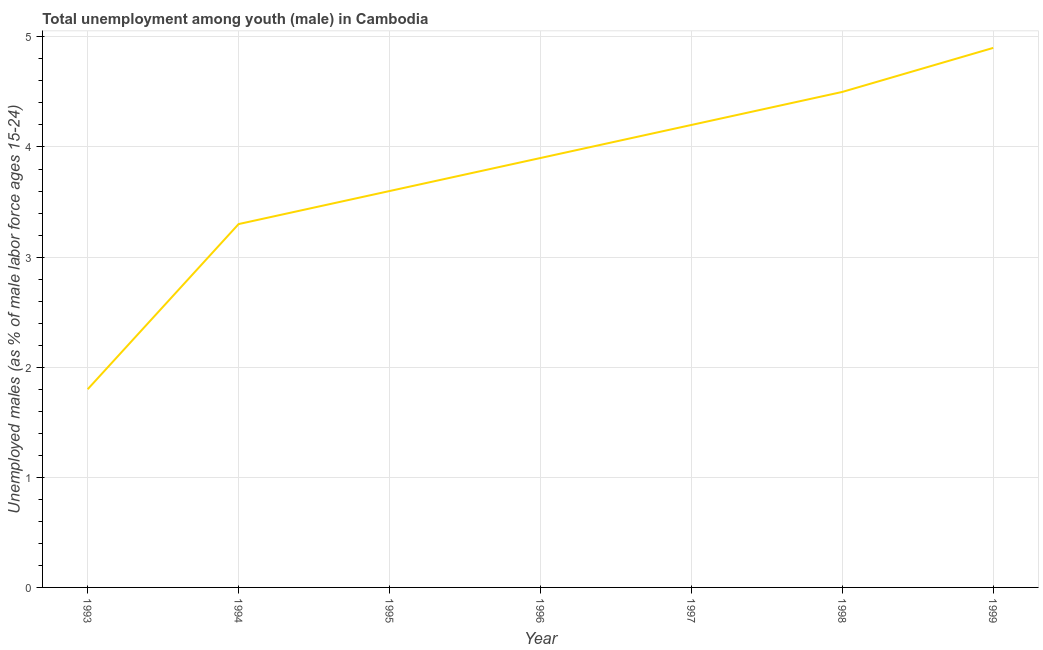Across all years, what is the maximum unemployed male youth population?
Offer a terse response. 4.9. Across all years, what is the minimum unemployed male youth population?
Offer a very short reply. 1.8. In which year was the unemployed male youth population minimum?
Keep it short and to the point. 1993. What is the sum of the unemployed male youth population?
Your answer should be very brief. 26.2. What is the difference between the unemployed male youth population in 1995 and 1998?
Ensure brevity in your answer.  -0.9. What is the average unemployed male youth population per year?
Keep it short and to the point. 3.74. What is the median unemployed male youth population?
Keep it short and to the point. 3.9. What is the ratio of the unemployed male youth population in 1996 to that in 1997?
Your answer should be very brief. 0.93. Is the unemployed male youth population in 1995 less than that in 1998?
Provide a short and direct response. Yes. What is the difference between the highest and the second highest unemployed male youth population?
Ensure brevity in your answer.  0.4. What is the difference between the highest and the lowest unemployed male youth population?
Your answer should be very brief. 3.1. In how many years, is the unemployed male youth population greater than the average unemployed male youth population taken over all years?
Ensure brevity in your answer.  4. How many lines are there?
Offer a very short reply. 1. How many years are there in the graph?
Give a very brief answer. 7. What is the title of the graph?
Give a very brief answer. Total unemployment among youth (male) in Cambodia. What is the label or title of the Y-axis?
Offer a very short reply. Unemployed males (as % of male labor force ages 15-24). What is the Unemployed males (as % of male labor force ages 15-24) in 1993?
Your answer should be very brief. 1.8. What is the Unemployed males (as % of male labor force ages 15-24) of 1994?
Offer a very short reply. 3.3. What is the Unemployed males (as % of male labor force ages 15-24) of 1995?
Ensure brevity in your answer.  3.6. What is the Unemployed males (as % of male labor force ages 15-24) in 1996?
Provide a succinct answer. 3.9. What is the Unemployed males (as % of male labor force ages 15-24) in 1997?
Give a very brief answer. 4.2. What is the Unemployed males (as % of male labor force ages 15-24) in 1999?
Make the answer very short. 4.9. What is the difference between the Unemployed males (as % of male labor force ages 15-24) in 1993 and 1994?
Offer a terse response. -1.5. What is the difference between the Unemployed males (as % of male labor force ages 15-24) in 1993 and 1996?
Offer a very short reply. -2.1. What is the difference between the Unemployed males (as % of male labor force ages 15-24) in 1993 and 1998?
Your answer should be very brief. -2.7. What is the difference between the Unemployed males (as % of male labor force ages 15-24) in 1994 and 1998?
Offer a very short reply. -1.2. What is the difference between the Unemployed males (as % of male labor force ages 15-24) in 1995 and 1996?
Provide a succinct answer. -0.3. What is the difference between the Unemployed males (as % of male labor force ages 15-24) in 1995 and 1997?
Your answer should be compact. -0.6. What is the difference between the Unemployed males (as % of male labor force ages 15-24) in 1996 and 1999?
Your answer should be compact. -1. What is the difference between the Unemployed males (as % of male labor force ages 15-24) in 1997 and 1999?
Ensure brevity in your answer.  -0.7. What is the difference between the Unemployed males (as % of male labor force ages 15-24) in 1998 and 1999?
Offer a very short reply. -0.4. What is the ratio of the Unemployed males (as % of male labor force ages 15-24) in 1993 to that in 1994?
Provide a short and direct response. 0.55. What is the ratio of the Unemployed males (as % of male labor force ages 15-24) in 1993 to that in 1995?
Keep it short and to the point. 0.5. What is the ratio of the Unemployed males (as % of male labor force ages 15-24) in 1993 to that in 1996?
Your answer should be compact. 0.46. What is the ratio of the Unemployed males (as % of male labor force ages 15-24) in 1993 to that in 1997?
Keep it short and to the point. 0.43. What is the ratio of the Unemployed males (as % of male labor force ages 15-24) in 1993 to that in 1999?
Ensure brevity in your answer.  0.37. What is the ratio of the Unemployed males (as % of male labor force ages 15-24) in 1994 to that in 1995?
Provide a short and direct response. 0.92. What is the ratio of the Unemployed males (as % of male labor force ages 15-24) in 1994 to that in 1996?
Ensure brevity in your answer.  0.85. What is the ratio of the Unemployed males (as % of male labor force ages 15-24) in 1994 to that in 1997?
Your answer should be compact. 0.79. What is the ratio of the Unemployed males (as % of male labor force ages 15-24) in 1994 to that in 1998?
Your response must be concise. 0.73. What is the ratio of the Unemployed males (as % of male labor force ages 15-24) in 1994 to that in 1999?
Keep it short and to the point. 0.67. What is the ratio of the Unemployed males (as % of male labor force ages 15-24) in 1995 to that in 1996?
Provide a short and direct response. 0.92. What is the ratio of the Unemployed males (as % of male labor force ages 15-24) in 1995 to that in 1997?
Provide a short and direct response. 0.86. What is the ratio of the Unemployed males (as % of male labor force ages 15-24) in 1995 to that in 1998?
Keep it short and to the point. 0.8. What is the ratio of the Unemployed males (as % of male labor force ages 15-24) in 1995 to that in 1999?
Make the answer very short. 0.73. What is the ratio of the Unemployed males (as % of male labor force ages 15-24) in 1996 to that in 1997?
Provide a short and direct response. 0.93. What is the ratio of the Unemployed males (as % of male labor force ages 15-24) in 1996 to that in 1998?
Offer a very short reply. 0.87. What is the ratio of the Unemployed males (as % of male labor force ages 15-24) in 1996 to that in 1999?
Your response must be concise. 0.8. What is the ratio of the Unemployed males (as % of male labor force ages 15-24) in 1997 to that in 1998?
Your answer should be compact. 0.93. What is the ratio of the Unemployed males (as % of male labor force ages 15-24) in 1997 to that in 1999?
Your answer should be very brief. 0.86. What is the ratio of the Unemployed males (as % of male labor force ages 15-24) in 1998 to that in 1999?
Offer a very short reply. 0.92. 